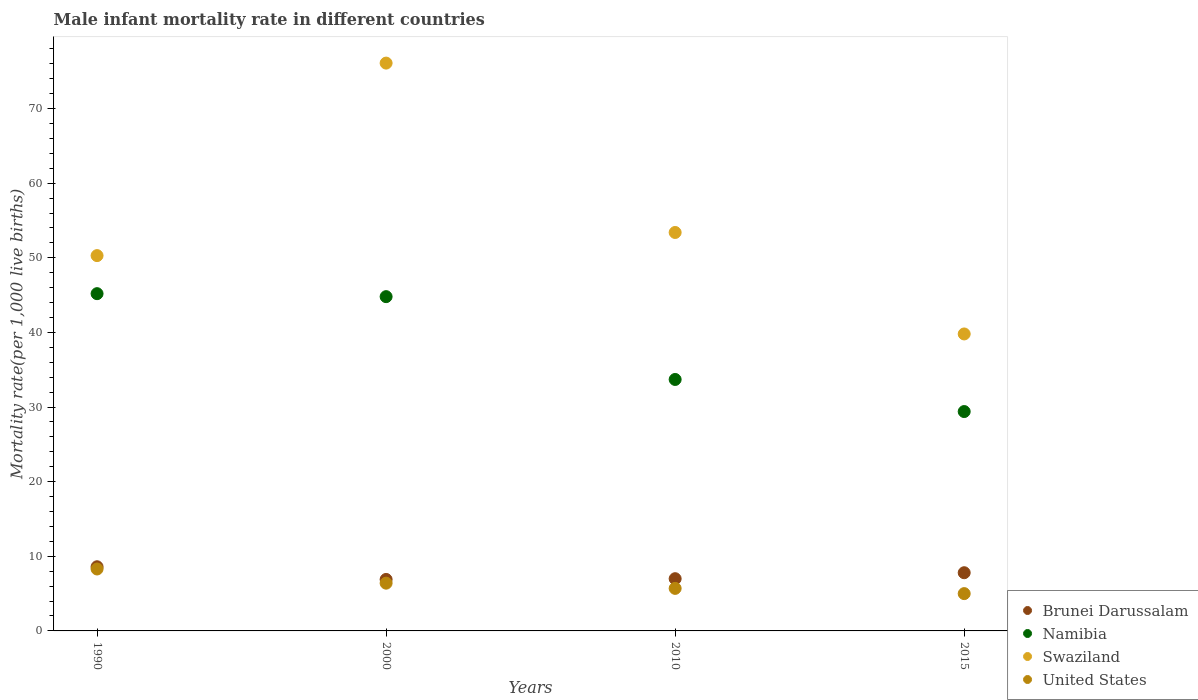What is the male infant mortality rate in United States in 1990?
Your answer should be very brief. 8.3. Across all years, what is the maximum male infant mortality rate in Swaziland?
Your answer should be compact. 76.1. Across all years, what is the minimum male infant mortality rate in Swaziland?
Make the answer very short. 39.8. In which year was the male infant mortality rate in Namibia minimum?
Keep it short and to the point. 2015. What is the total male infant mortality rate in Brunei Darussalam in the graph?
Ensure brevity in your answer.  30.3. What is the difference between the male infant mortality rate in United States in 2010 and that in 2015?
Your response must be concise. 0.7. What is the difference between the male infant mortality rate in Brunei Darussalam in 2015 and the male infant mortality rate in Namibia in 2000?
Provide a succinct answer. -37. What is the average male infant mortality rate in Namibia per year?
Give a very brief answer. 38.27. In the year 2010, what is the difference between the male infant mortality rate in Swaziland and male infant mortality rate in Namibia?
Provide a succinct answer. 19.7. What is the ratio of the male infant mortality rate in Namibia in 2000 to that in 2015?
Your answer should be compact. 1.52. Is the difference between the male infant mortality rate in Swaziland in 1990 and 2010 greater than the difference between the male infant mortality rate in Namibia in 1990 and 2010?
Keep it short and to the point. No. What is the difference between the highest and the second highest male infant mortality rate in United States?
Your answer should be very brief. 1.9. What is the difference between the highest and the lowest male infant mortality rate in United States?
Your response must be concise. 3.3. In how many years, is the male infant mortality rate in United States greater than the average male infant mortality rate in United States taken over all years?
Provide a succinct answer. 2. Is it the case that in every year, the sum of the male infant mortality rate in Namibia and male infant mortality rate in Swaziland  is greater than the male infant mortality rate in Brunei Darussalam?
Offer a very short reply. Yes. Does the male infant mortality rate in Brunei Darussalam monotonically increase over the years?
Keep it short and to the point. No. Is the male infant mortality rate in United States strictly greater than the male infant mortality rate in Namibia over the years?
Your answer should be very brief. No. Is the male infant mortality rate in United States strictly less than the male infant mortality rate in Swaziland over the years?
Make the answer very short. Yes. How many dotlines are there?
Your answer should be very brief. 4. How many years are there in the graph?
Provide a succinct answer. 4. What is the difference between two consecutive major ticks on the Y-axis?
Give a very brief answer. 10. Are the values on the major ticks of Y-axis written in scientific E-notation?
Keep it short and to the point. No. Does the graph contain any zero values?
Offer a very short reply. No. Where does the legend appear in the graph?
Provide a succinct answer. Bottom right. How many legend labels are there?
Your answer should be very brief. 4. How are the legend labels stacked?
Make the answer very short. Vertical. What is the title of the graph?
Your answer should be compact. Male infant mortality rate in different countries. Does "Georgia" appear as one of the legend labels in the graph?
Offer a terse response. No. What is the label or title of the X-axis?
Offer a very short reply. Years. What is the label or title of the Y-axis?
Your answer should be very brief. Mortality rate(per 1,0 live births). What is the Mortality rate(per 1,000 live births) in Brunei Darussalam in 1990?
Ensure brevity in your answer.  8.6. What is the Mortality rate(per 1,000 live births) in Namibia in 1990?
Ensure brevity in your answer.  45.2. What is the Mortality rate(per 1,000 live births) of Swaziland in 1990?
Provide a succinct answer. 50.3. What is the Mortality rate(per 1,000 live births) of United States in 1990?
Keep it short and to the point. 8.3. What is the Mortality rate(per 1,000 live births) of Namibia in 2000?
Provide a succinct answer. 44.8. What is the Mortality rate(per 1,000 live births) in Swaziland in 2000?
Your answer should be very brief. 76.1. What is the Mortality rate(per 1,000 live births) in United States in 2000?
Provide a succinct answer. 6.4. What is the Mortality rate(per 1,000 live births) of Namibia in 2010?
Your answer should be compact. 33.7. What is the Mortality rate(per 1,000 live births) in Swaziland in 2010?
Offer a very short reply. 53.4. What is the Mortality rate(per 1,000 live births) in United States in 2010?
Offer a very short reply. 5.7. What is the Mortality rate(per 1,000 live births) of Namibia in 2015?
Offer a terse response. 29.4. What is the Mortality rate(per 1,000 live births) of Swaziland in 2015?
Provide a short and direct response. 39.8. Across all years, what is the maximum Mortality rate(per 1,000 live births) of Namibia?
Keep it short and to the point. 45.2. Across all years, what is the maximum Mortality rate(per 1,000 live births) of Swaziland?
Your response must be concise. 76.1. Across all years, what is the minimum Mortality rate(per 1,000 live births) of Namibia?
Offer a very short reply. 29.4. Across all years, what is the minimum Mortality rate(per 1,000 live births) of Swaziland?
Provide a short and direct response. 39.8. What is the total Mortality rate(per 1,000 live births) of Brunei Darussalam in the graph?
Make the answer very short. 30.3. What is the total Mortality rate(per 1,000 live births) in Namibia in the graph?
Keep it short and to the point. 153.1. What is the total Mortality rate(per 1,000 live births) in Swaziland in the graph?
Provide a short and direct response. 219.6. What is the total Mortality rate(per 1,000 live births) in United States in the graph?
Provide a short and direct response. 25.4. What is the difference between the Mortality rate(per 1,000 live births) of Swaziland in 1990 and that in 2000?
Make the answer very short. -25.8. What is the difference between the Mortality rate(per 1,000 live births) of United States in 1990 and that in 2000?
Provide a short and direct response. 1.9. What is the difference between the Mortality rate(per 1,000 live births) of Namibia in 1990 and that in 2010?
Provide a short and direct response. 11.5. What is the difference between the Mortality rate(per 1,000 live births) of Namibia in 1990 and that in 2015?
Make the answer very short. 15.8. What is the difference between the Mortality rate(per 1,000 live births) in Swaziland in 1990 and that in 2015?
Make the answer very short. 10.5. What is the difference between the Mortality rate(per 1,000 live births) in United States in 1990 and that in 2015?
Offer a terse response. 3.3. What is the difference between the Mortality rate(per 1,000 live births) in Namibia in 2000 and that in 2010?
Keep it short and to the point. 11.1. What is the difference between the Mortality rate(per 1,000 live births) in Swaziland in 2000 and that in 2010?
Offer a very short reply. 22.7. What is the difference between the Mortality rate(per 1,000 live births) in United States in 2000 and that in 2010?
Give a very brief answer. 0.7. What is the difference between the Mortality rate(per 1,000 live births) of Swaziland in 2000 and that in 2015?
Make the answer very short. 36.3. What is the difference between the Mortality rate(per 1,000 live births) in United States in 2000 and that in 2015?
Your answer should be very brief. 1.4. What is the difference between the Mortality rate(per 1,000 live births) in Brunei Darussalam in 2010 and that in 2015?
Your response must be concise. -0.8. What is the difference between the Mortality rate(per 1,000 live births) in Brunei Darussalam in 1990 and the Mortality rate(per 1,000 live births) in Namibia in 2000?
Keep it short and to the point. -36.2. What is the difference between the Mortality rate(per 1,000 live births) of Brunei Darussalam in 1990 and the Mortality rate(per 1,000 live births) of Swaziland in 2000?
Offer a terse response. -67.5. What is the difference between the Mortality rate(per 1,000 live births) in Brunei Darussalam in 1990 and the Mortality rate(per 1,000 live births) in United States in 2000?
Offer a terse response. 2.2. What is the difference between the Mortality rate(per 1,000 live births) of Namibia in 1990 and the Mortality rate(per 1,000 live births) of Swaziland in 2000?
Offer a very short reply. -30.9. What is the difference between the Mortality rate(per 1,000 live births) of Namibia in 1990 and the Mortality rate(per 1,000 live births) of United States in 2000?
Your answer should be very brief. 38.8. What is the difference between the Mortality rate(per 1,000 live births) of Swaziland in 1990 and the Mortality rate(per 1,000 live births) of United States in 2000?
Make the answer very short. 43.9. What is the difference between the Mortality rate(per 1,000 live births) of Brunei Darussalam in 1990 and the Mortality rate(per 1,000 live births) of Namibia in 2010?
Your answer should be very brief. -25.1. What is the difference between the Mortality rate(per 1,000 live births) in Brunei Darussalam in 1990 and the Mortality rate(per 1,000 live births) in Swaziland in 2010?
Offer a very short reply. -44.8. What is the difference between the Mortality rate(per 1,000 live births) in Brunei Darussalam in 1990 and the Mortality rate(per 1,000 live births) in United States in 2010?
Provide a succinct answer. 2.9. What is the difference between the Mortality rate(per 1,000 live births) in Namibia in 1990 and the Mortality rate(per 1,000 live births) in Swaziland in 2010?
Ensure brevity in your answer.  -8.2. What is the difference between the Mortality rate(per 1,000 live births) in Namibia in 1990 and the Mortality rate(per 1,000 live births) in United States in 2010?
Provide a short and direct response. 39.5. What is the difference between the Mortality rate(per 1,000 live births) in Swaziland in 1990 and the Mortality rate(per 1,000 live births) in United States in 2010?
Provide a succinct answer. 44.6. What is the difference between the Mortality rate(per 1,000 live births) in Brunei Darussalam in 1990 and the Mortality rate(per 1,000 live births) in Namibia in 2015?
Your response must be concise. -20.8. What is the difference between the Mortality rate(per 1,000 live births) of Brunei Darussalam in 1990 and the Mortality rate(per 1,000 live births) of Swaziland in 2015?
Provide a succinct answer. -31.2. What is the difference between the Mortality rate(per 1,000 live births) of Brunei Darussalam in 1990 and the Mortality rate(per 1,000 live births) of United States in 2015?
Offer a very short reply. 3.6. What is the difference between the Mortality rate(per 1,000 live births) in Namibia in 1990 and the Mortality rate(per 1,000 live births) in United States in 2015?
Your answer should be compact. 40.2. What is the difference between the Mortality rate(per 1,000 live births) in Swaziland in 1990 and the Mortality rate(per 1,000 live births) in United States in 2015?
Provide a succinct answer. 45.3. What is the difference between the Mortality rate(per 1,000 live births) in Brunei Darussalam in 2000 and the Mortality rate(per 1,000 live births) in Namibia in 2010?
Your answer should be very brief. -26.8. What is the difference between the Mortality rate(per 1,000 live births) in Brunei Darussalam in 2000 and the Mortality rate(per 1,000 live births) in Swaziland in 2010?
Give a very brief answer. -46.5. What is the difference between the Mortality rate(per 1,000 live births) in Brunei Darussalam in 2000 and the Mortality rate(per 1,000 live births) in United States in 2010?
Your answer should be very brief. 1.2. What is the difference between the Mortality rate(per 1,000 live births) of Namibia in 2000 and the Mortality rate(per 1,000 live births) of United States in 2010?
Provide a short and direct response. 39.1. What is the difference between the Mortality rate(per 1,000 live births) in Swaziland in 2000 and the Mortality rate(per 1,000 live births) in United States in 2010?
Make the answer very short. 70.4. What is the difference between the Mortality rate(per 1,000 live births) in Brunei Darussalam in 2000 and the Mortality rate(per 1,000 live births) in Namibia in 2015?
Ensure brevity in your answer.  -22.5. What is the difference between the Mortality rate(per 1,000 live births) in Brunei Darussalam in 2000 and the Mortality rate(per 1,000 live births) in Swaziland in 2015?
Your answer should be very brief. -32.9. What is the difference between the Mortality rate(per 1,000 live births) of Namibia in 2000 and the Mortality rate(per 1,000 live births) of United States in 2015?
Offer a terse response. 39.8. What is the difference between the Mortality rate(per 1,000 live births) of Swaziland in 2000 and the Mortality rate(per 1,000 live births) of United States in 2015?
Keep it short and to the point. 71.1. What is the difference between the Mortality rate(per 1,000 live births) of Brunei Darussalam in 2010 and the Mortality rate(per 1,000 live births) of Namibia in 2015?
Make the answer very short. -22.4. What is the difference between the Mortality rate(per 1,000 live births) in Brunei Darussalam in 2010 and the Mortality rate(per 1,000 live births) in Swaziland in 2015?
Offer a terse response. -32.8. What is the difference between the Mortality rate(per 1,000 live births) in Brunei Darussalam in 2010 and the Mortality rate(per 1,000 live births) in United States in 2015?
Offer a terse response. 2. What is the difference between the Mortality rate(per 1,000 live births) in Namibia in 2010 and the Mortality rate(per 1,000 live births) in United States in 2015?
Your response must be concise. 28.7. What is the difference between the Mortality rate(per 1,000 live births) in Swaziland in 2010 and the Mortality rate(per 1,000 live births) in United States in 2015?
Keep it short and to the point. 48.4. What is the average Mortality rate(per 1,000 live births) of Brunei Darussalam per year?
Provide a short and direct response. 7.58. What is the average Mortality rate(per 1,000 live births) in Namibia per year?
Your answer should be compact. 38.27. What is the average Mortality rate(per 1,000 live births) of Swaziland per year?
Offer a terse response. 54.9. What is the average Mortality rate(per 1,000 live births) of United States per year?
Offer a terse response. 6.35. In the year 1990, what is the difference between the Mortality rate(per 1,000 live births) in Brunei Darussalam and Mortality rate(per 1,000 live births) in Namibia?
Your answer should be very brief. -36.6. In the year 1990, what is the difference between the Mortality rate(per 1,000 live births) in Brunei Darussalam and Mortality rate(per 1,000 live births) in Swaziland?
Ensure brevity in your answer.  -41.7. In the year 1990, what is the difference between the Mortality rate(per 1,000 live births) in Brunei Darussalam and Mortality rate(per 1,000 live births) in United States?
Keep it short and to the point. 0.3. In the year 1990, what is the difference between the Mortality rate(per 1,000 live births) of Namibia and Mortality rate(per 1,000 live births) of United States?
Offer a terse response. 36.9. In the year 2000, what is the difference between the Mortality rate(per 1,000 live births) of Brunei Darussalam and Mortality rate(per 1,000 live births) of Namibia?
Offer a very short reply. -37.9. In the year 2000, what is the difference between the Mortality rate(per 1,000 live births) of Brunei Darussalam and Mortality rate(per 1,000 live births) of Swaziland?
Offer a terse response. -69.2. In the year 2000, what is the difference between the Mortality rate(per 1,000 live births) of Brunei Darussalam and Mortality rate(per 1,000 live births) of United States?
Provide a short and direct response. 0.5. In the year 2000, what is the difference between the Mortality rate(per 1,000 live births) in Namibia and Mortality rate(per 1,000 live births) in Swaziland?
Your response must be concise. -31.3. In the year 2000, what is the difference between the Mortality rate(per 1,000 live births) in Namibia and Mortality rate(per 1,000 live births) in United States?
Offer a very short reply. 38.4. In the year 2000, what is the difference between the Mortality rate(per 1,000 live births) of Swaziland and Mortality rate(per 1,000 live births) of United States?
Ensure brevity in your answer.  69.7. In the year 2010, what is the difference between the Mortality rate(per 1,000 live births) of Brunei Darussalam and Mortality rate(per 1,000 live births) of Namibia?
Provide a succinct answer. -26.7. In the year 2010, what is the difference between the Mortality rate(per 1,000 live births) of Brunei Darussalam and Mortality rate(per 1,000 live births) of Swaziland?
Ensure brevity in your answer.  -46.4. In the year 2010, what is the difference between the Mortality rate(per 1,000 live births) of Brunei Darussalam and Mortality rate(per 1,000 live births) of United States?
Give a very brief answer. 1.3. In the year 2010, what is the difference between the Mortality rate(per 1,000 live births) in Namibia and Mortality rate(per 1,000 live births) in Swaziland?
Your answer should be very brief. -19.7. In the year 2010, what is the difference between the Mortality rate(per 1,000 live births) of Swaziland and Mortality rate(per 1,000 live births) of United States?
Provide a short and direct response. 47.7. In the year 2015, what is the difference between the Mortality rate(per 1,000 live births) of Brunei Darussalam and Mortality rate(per 1,000 live births) of Namibia?
Provide a succinct answer. -21.6. In the year 2015, what is the difference between the Mortality rate(per 1,000 live births) of Brunei Darussalam and Mortality rate(per 1,000 live births) of Swaziland?
Make the answer very short. -32. In the year 2015, what is the difference between the Mortality rate(per 1,000 live births) of Namibia and Mortality rate(per 1,000 live births) of Swaziland?
Ensure brevity in your answer.  -10.4. In the year 2015, what is the difference between the Mortality rate(per 1,000 live births) of Namibia and Mortality rate(per 1,000 live births) of United States?
Your answer should be compact. 24.4. In the year 2015, what is the difference between the Mortality rate(per 1,000 live births) of Swaziland and Mortality rate(per 1,000 live births) of United States?
Your answer should be very brief. 34.8. What is the ratio of the Mortality rate(per 1,000 live births) of Brunei Darussalam in 1990 to that in 2000?
Your answer should be compact. 1.25. What is the ratio of the Mortality rate(per 1,000 live births) of Namibia in 1990 to that in 2000?
Make the answer very short. 1.01. What is the ratio of the Mortality rate(per 1,000 live births) of Swaziland in 1990 to that in 2000?
Your answer should be compact. 0.66. What is the ratio of the Mortality rate(per 1,000 live births) in United States in 1990 to that in 2000?
Your answer should be very brief. 1.3. What is the ratio of the Mortality rate(per 1,000 live births) in Brunei Darussalam in 1990 to that in 2010?
Your answer should be compact. 1.23. What is the ratio of the Mortality rate(per 1,000 live births) of Namibia in 1990 to that in 2010?
Your answer should be very brief. 1.34. What is the ratio of the Mortality rate(per 1,000 live births) in Swaziland in 1990 to that in 2010?
Offer a very short reply. 0.94. What is the ratio of the Mortality rate(per 1,000 live births) in United States in 1990 to that in 2010?
Provide a short and direct response. 1.46. What is the ratio of the Mortality rate(per 1,000 live births) in Brunei Darussalam in 1990 to that in 2015?
Provide a short and direct response. 1.1. What is the ratio of the Mortality rate(per 1,000 live births) of Namibia in 1990 to that in 2015?
Give a very brief answer. 1.54. What is the ratio of the Mortality rate(per 1,000 live births) in Swaziland in 1990 to that in 2015?
Your response must be concise. 1.26. What is the ratio of the Mortality rate(per 1,000 live births) of United States in 1990 to that in 2015?
Provide a succinct answer. 1.66. What is the ratio of the Mortality rate(per 1,000 live births) of Brunei Darussalam in 2000 to that in 2010?
Offer a terse response. 0.99. What is the ratio of the Mortality rate(per 1,000 live births) of Namibia in 2000 to that in 2010?
Offer a terse response. 1.33. What is the ratio of the Mortality rate(per 1,000 live births) in Swaziland in 2000 to that in 2010?
Your answer should be very brief. 1.43. What is the ratio of the Mortality rate(per 1,000 live births) of United States in 2000 to that in 2010?
Your answer should be very brief. 1.12. What is the ratio of the Mortality rate(per 1,000 live births) of Brunei Darussalam in 2000 to that in 2015?
Give a very brief answer. 0.88. What is the ratio of the Mortality rate(per 1,000 live births) in Namibia in 2000 to that in 2015?
Provide a succinct answer. 1.52. What is the ratio of the Mortality rate(per 1,000 live births) in Swaziland in 2000 to that in 2015?
Provide a succinct answer. 1.91. What is the ratio of the Mortality rate(per 1,000 live births) of United States in 2000 to that in 2015?
Ensure brevity in your answer.  1.28. What is the ratio of the Mortality rate(per 1,000 live births) in Brunei Darussalam in 2010 to that in 2015?
Make the answer very short. 0.9. What is the ratio of the Mortality rate(per 1,000 live births) of Namibia in 2010 to that in 2015?
Your answer should be compact. 1.15. What is the ratio of the Mortality rate(per 1,000 live births) of Swaziland in 2010 to that in 2015?
Provide a short and direct response. 1.34. What is the ratio of the Mortality rate(per 1,000 live births) of United States in 2010 to that in 2015?
Provide a succinct answer. 1.14. What is the difference between the highest and the second highest Mortality rate(per 1,000 live births) of Swaziland?
Provide a succinct answer. 22.7. What is the difference between the highest and the lowest Mortality rate(per 1,000 live births) in Swaziland?
Offer a very short reply. 36.3. What is the difference between the highest and the lowest Mortality rate(per 1,000 live births) of United States?
Your response must be concise. 3.3. 